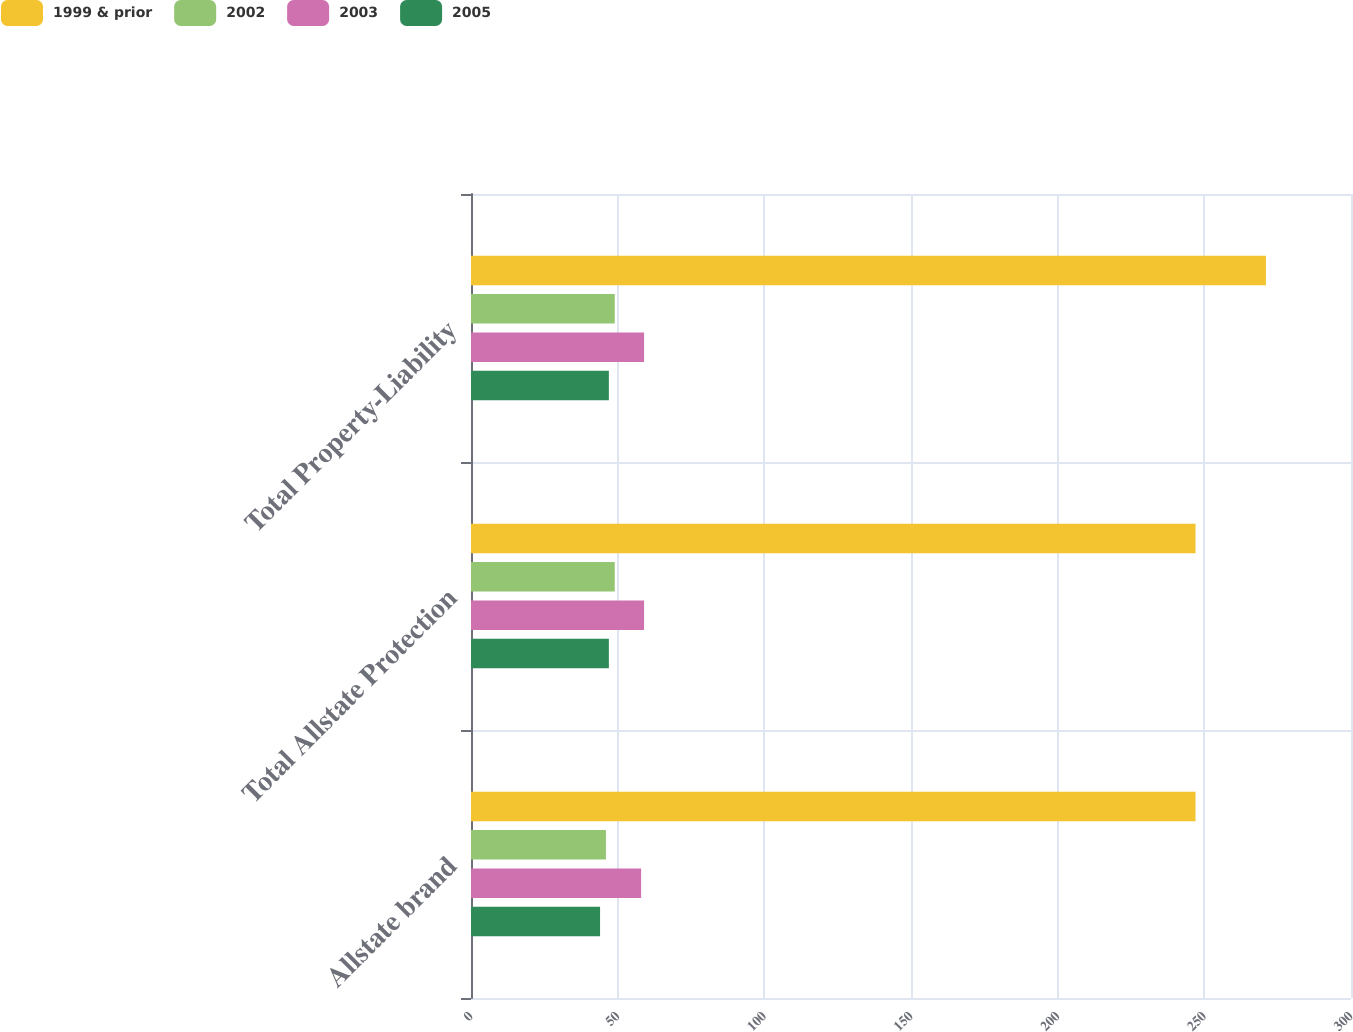Convert chart to OTSL. <chart><loc_0><loc_0><loc_500><loc_500><stacked_bar_chart><ecel><fcel>Allstate brand<fcel>Total Allstate Protection<fcel>Total Property-Liability<nl><fcel>1999 & prior<fcel>247<fcel>247<fcel>271<nl><fcel>2002<fcel>46<fcel>49<fcel>49<nl><fcel>2003<fcel>58<fcel>59<fcel>59<nl><fcel>2005<fcel>44<fcel>47<fcel>47<nl></chart> 